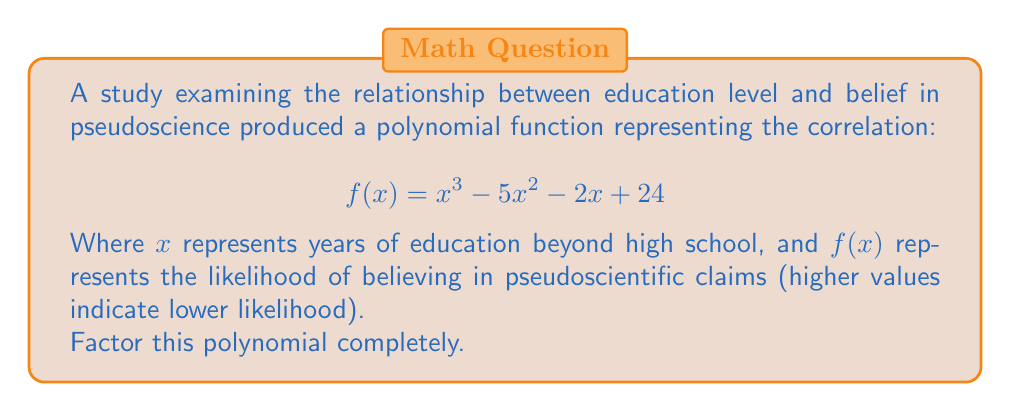Teach me how to tackle this problem. To factor this polynomial, we'll follow these steps:

1) First, let's check if there are any rational roots using the rational root theorem. The possible rational roots are the factors of the constant term (24): ±1, ±2, ±3, ±4, ±6, ±8, ±12, ±24.

2) Testing these values, we find that $f(4) = 0$. So $(x-4)$ is a factor.

3) We can use polynomial long division to divide $f(x)$ by $(x-4)$:

   $x^3 - 5x^2 - 2x + 24 = (x-4)(x^2 + x - 6)$

4) Now we need to factor the quadratic $x^2 + x - 6$. We can do this by finding two numbers that multiply to give -6 and add to give 1. These numbers are 3 and -2.

5) So we can factor $x^2 + x - 6$ as $(x+3)(x-2)$

Therefore, the complete factorization is:

$$ f(x) = (x-4)(x+3)(x-2) $$

This factorization reveals that the function reaches zero (indicating no belief in pseudoscience) when $x = 4$, $x = -3$, or $x = 2$. From a psychological perspective, this suggests that both very low and very high levels of education (2 and 4 years beyond high school) are associated with lower belief in pseudoscience, while a moderate level (-3 years, which doesn't have a real-world interpretation in this context) is also associated with lower belief.
Answer: $$ f(x) = (x-4)(x+3)(x-2) $$ 